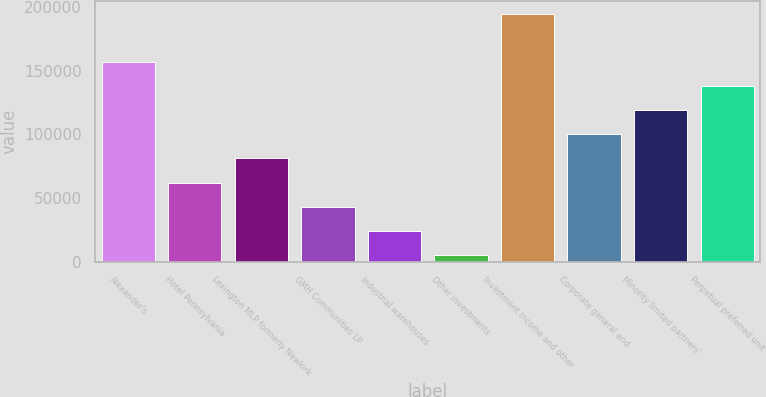Convert chart. <chart><loc_0><loc_0><loc_500><loc_500><bar_chart><fcel>Alexander's<fcel>Hotel Pennsylvania<fcel>Lexington MLP formerly Newkirk<fcel>GMH Communities LP<fcel>Industrial warehouses<fcel>Other investments<fcel>Investment income and other<fcel>Corporate general and<fcel>Minority limited partners'<fcel>Perpetual preferred unit<nl><fcel>156945<fcel>62178.6<fcel>81131.8<fcel>43225.4<fcel>24272.2<fcel>5319<fcel>194851<fcel>100085<fcel>119038<fcel>137991<nl></chart> 